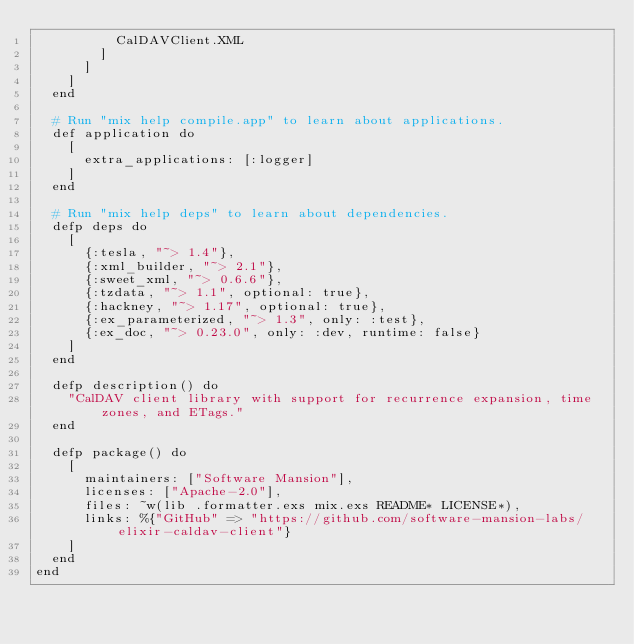<code> <loc_0><loc_0><loc_500><loc_500><_Elixir_>          CalDAVClient.XML
        ]
      ]
    ]
  end

  # Run "mix help compile.app" to learn about applications.
  def application do
    [
      extra_applications: [:logger]
    ]
  end

  # Run "mix help deps" to learn about dependencies.
  defp deps do
    [
      {:tesla, "~> 1.4"},
      {:xml_builder, "~> 2.1"},
      {:sweet_xml, "~> 0.6.6"},
      {:tzdata, "~> 1.1", optional: true},
      {:hackney, "~> 1.17", optional: true},
      {:ex_parameterized, "~> 1.3", only: :test},
      {:ex_doc, "~> 0.23.0", only: :dev, runtime: false}
    ]
  end

  defp description() do
    "CalDAV client library with support for recurrence expansion, time zones, and ETags."
  end

  defp package() do
    [
      maintainers: ["Software Mansion"],
      licenses: ["Apache-2.0"],
      files: ~w(lib .formatter.exs mix.exs README* LICENSE*),
      links: %{"GitHub" => "https://github.com/software-mansion-labs/elixir-caldav-client"}
    ]
  end
end
</code> 